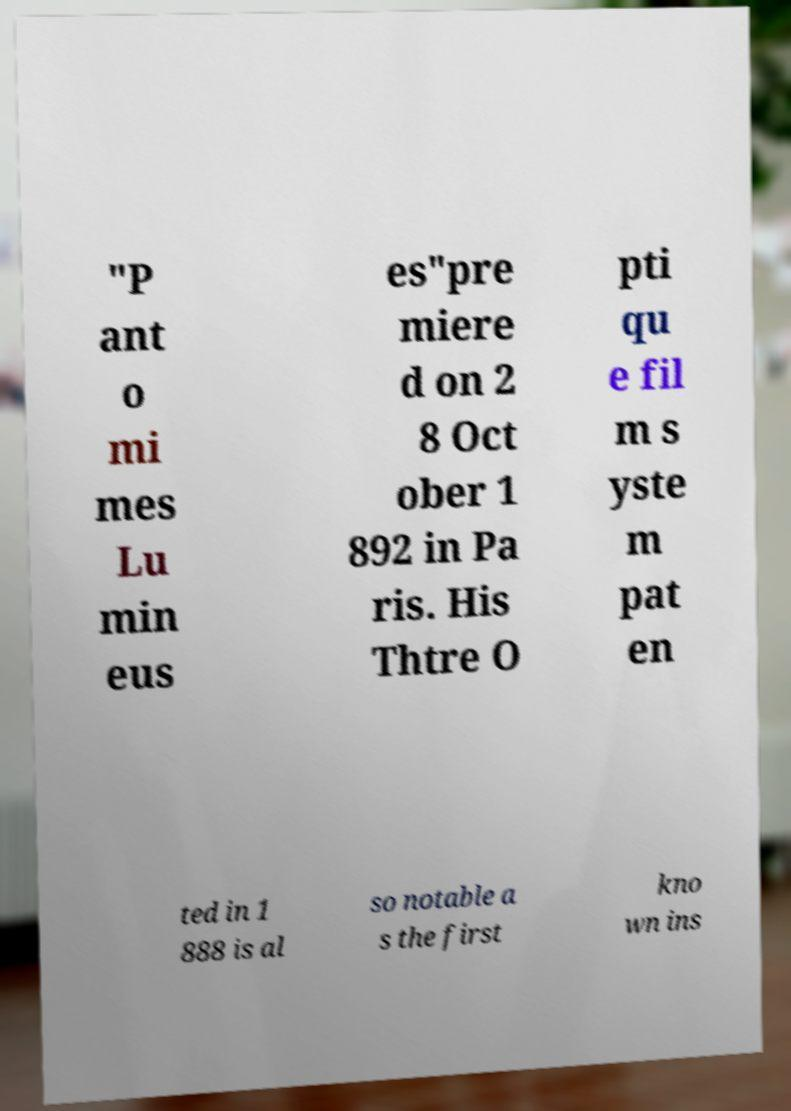What messages or text are displayed in this image? I need them in a readable, typed format. "P ant o mi mes Lu min eus es"pre miere d on 2 8 Oct ober 1 892 in Pa ris. His Thtre O pti qu e fil m s yste m pat en ted in 1 888 is al so notable a s the first kno wn ins 